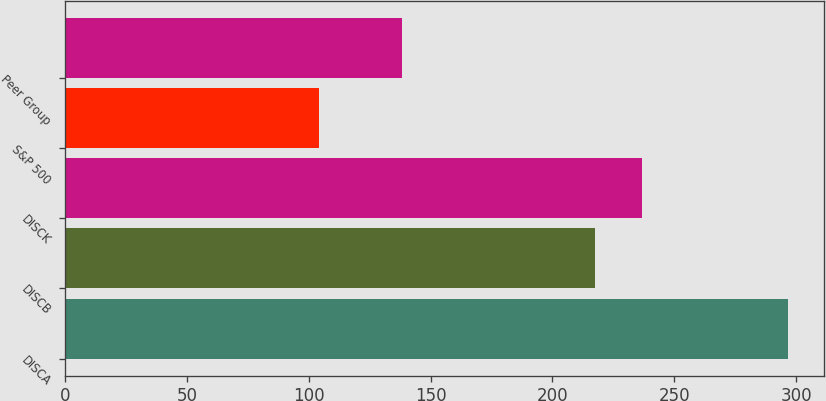<chart> <loc_0><loc_0><loc_500><loc_500><bar_chart><fcel>DISCA<fcel>DISCB<fcel>DISCK<fcel>S&P 500<fcel>Peer Group<nl><fcel>296.67<fcel>217.56<fcel>236.8<fcel>104.23<fcel>138.19<nl></chart> 